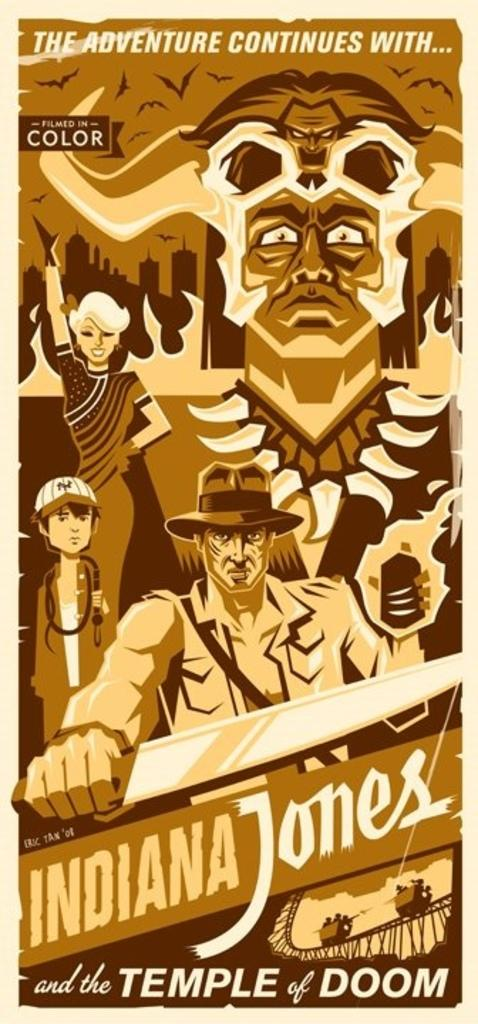<image>
Render a clear and concise summary of the photo. A movie poster advertising Indiana Jones and The Temple of Doom. 